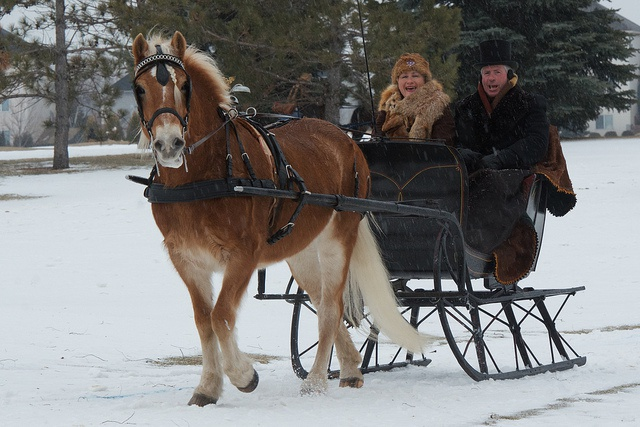Describe the objects in this image and their specific colors. I can see horse in black, maroon, and darkgray tones, people in black, brown, and maroon tones, and people in black, gray, and maroon tones in this image. 